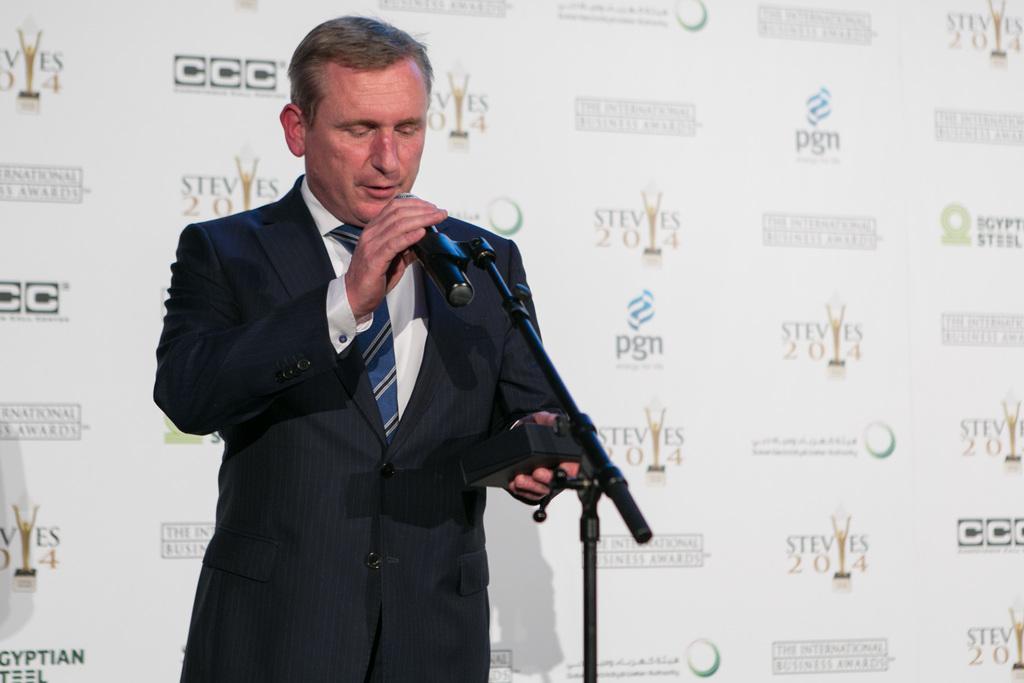In one or two sentences, can you explain what this image depicts? In this image there is a person wearing black color suit holding a microphone in his right hand and at the background there is a white color sheet on which some words are written 